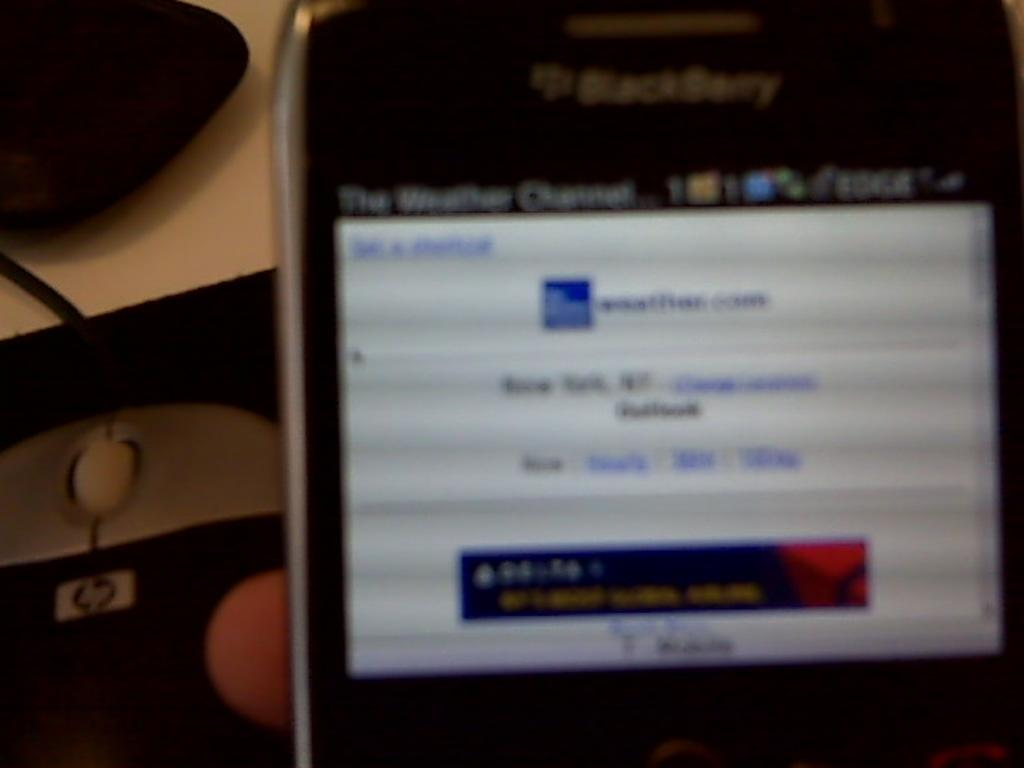What is the person in the image holding? The person is holding a mobile in the image. What can be seen in the background of the image? There is a mouse and an object in black color in the background of the image. What type of cake is the person holding in their pocket in the image? There is no cake or pocket visible in the image. 